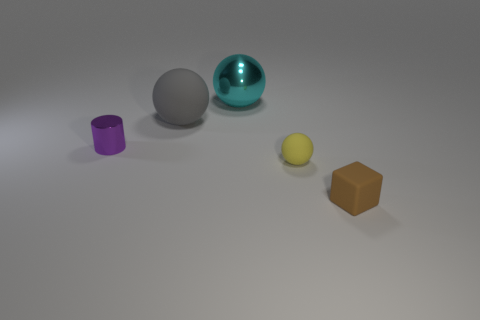There is a small rubber object in front of the rubber ball in front of the tiny purple metal thing; what is its color?
Keep it short and to the point. Brown. There is a big gray object that is the same shape as the large cyan thing; what material is it?
Ensure brevity in your answer.  Rubber. The metallic thing right of the matte sphere that is to the left of the big thing behind the gray matte object is what color?
Your answer should be very brief. Cyan. How many objects are either small red shiny things or shiny spheres?
Offer a terse response. 1. How many tiny yellow matte objects are the same shape as the large rubber object?
Ensure brevity in your answer.  1. Is the small yellow ball made of the same material as the big ball that is to the right of the large gray sphere?
Provide a short and direct response. No. There is a ball that is made of the same material as the gray thing; what is its size?
Offer a very short reply. Small. How big is the rubber thing behind the tiny shiny object?
Make the answer very short. Large. What number of brown rubber things are the same size as the purple cylinder?
Ensure brevity in your answer.  1. Is there a small ball of the same color as the large rubber sphere?
Your answer should be compact. No. 